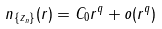Convert formula to latex. <formula><loc_0><loc_0><loc_500><loc_500>n _ { \{ z _ { n } \} } ( r ) = C _ { 0 } r ^ { q } + o ( r ^ { q } )</formula> 